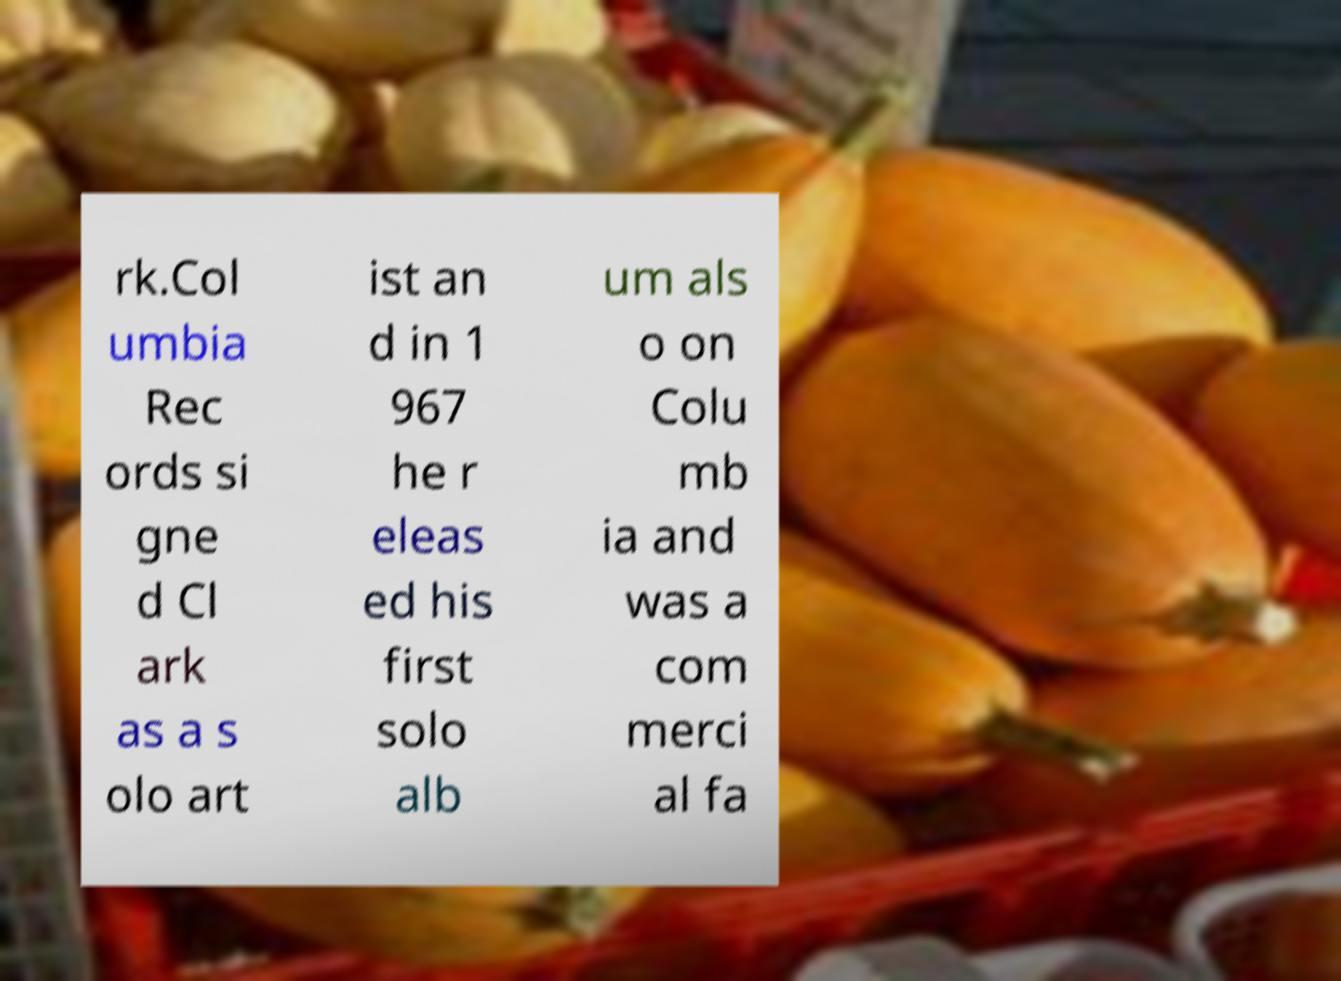What messages or text are displayed in this image? I need them in a readable, typed format. rk.Col umbia Rec ords si gne d Cl ark as a s olo art ist an d in 1 967 he r eleas ed his first solo alb um als o on Colu mb ia and was a com merci al fa 